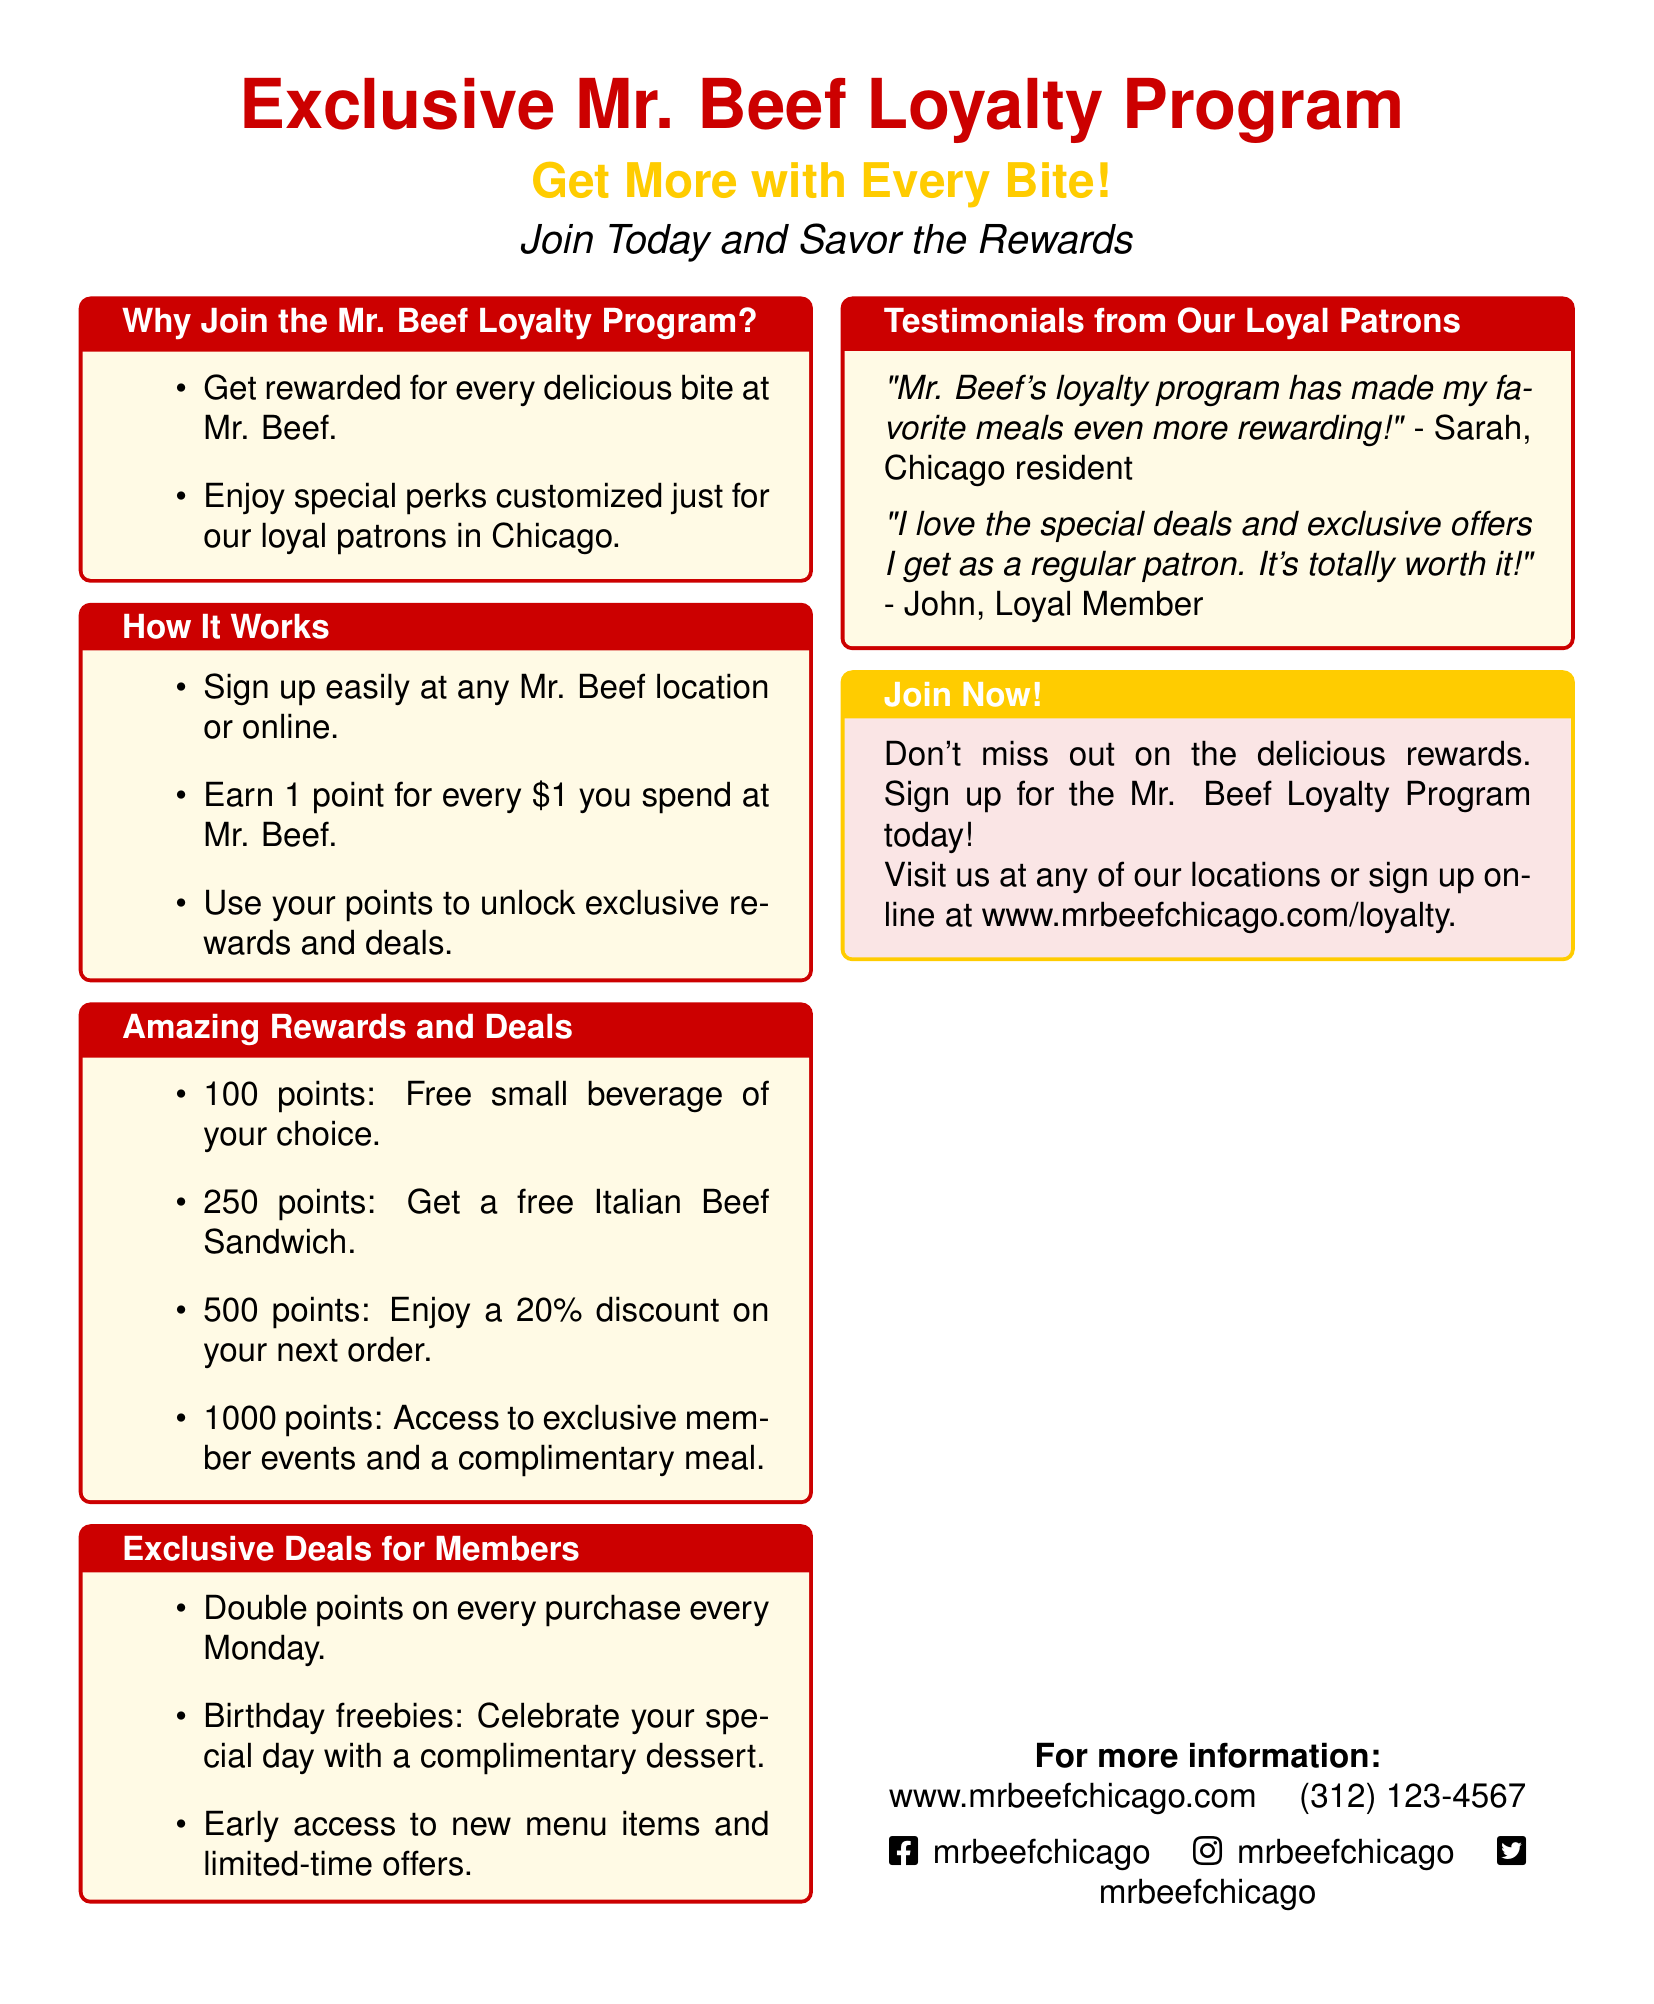What is the program being advertised? The document promotes the Mr. Beef Loyalty Program, highlighting its benefits and features.
Answer: Mr. Beef Loyalty Program How many points do you earn per dollar spent? The document specifies that you earn 1 point for every dollar spent at Mr. Beef.
Answer: 1 point What reward do you get at 250 points? The document states that at 250 points, you can get a free Italian Beef Sandwich.
Answer: Free Italian Beef Sandwich What exclusive deal is offered every Monday? The document mentions that members can earn double points on every purchase made on Mondays.
Answer: Double points What do you receive on your birthday as a member? The advertisement highlights that members receive a complimentary dessert on their birthday.
Answer: Complimentary dessert How can you sign up for the loyalty program? According to the document, you can sign up at any Mr. Beef location or online.
Answer: At any location or online What is the maximum number of points mentioned for a specific reward? The advertisement lists 1000 points for accessing exclusive member events and a complimentary meal.
Answer: 1000 points Who is quoted in the testimonials section? The testimonials section includes quotes from Sarah and John, who express positive feedback about the loyalty program.
Answer: Sarah and John 